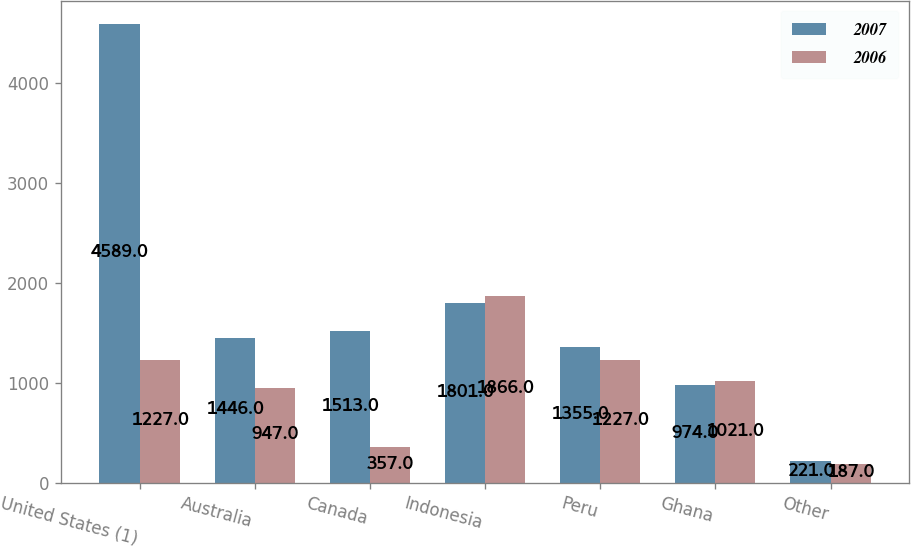Convert chart to OTSL. <chart><loc_0><loc_0><loc_500><loc_500><stacked_bar_chart><ecel><fcel>United States (1)<fcel>Australia<fcel>Canada<fcel>Indonesia<fcel>Peru<fcel>Ghana<fcel>Other<nl><fcel>2007<fcel>4589<fcel>1446<fcel>1513<fcel>1801<fcel>1355<fcel>974<fcel>221<nl><fcel>2006<fcel>1227<fcel>947<fcel>357<fcel>1866<fcel>1227<fcel>1021<fcel>187<nl></chart> 